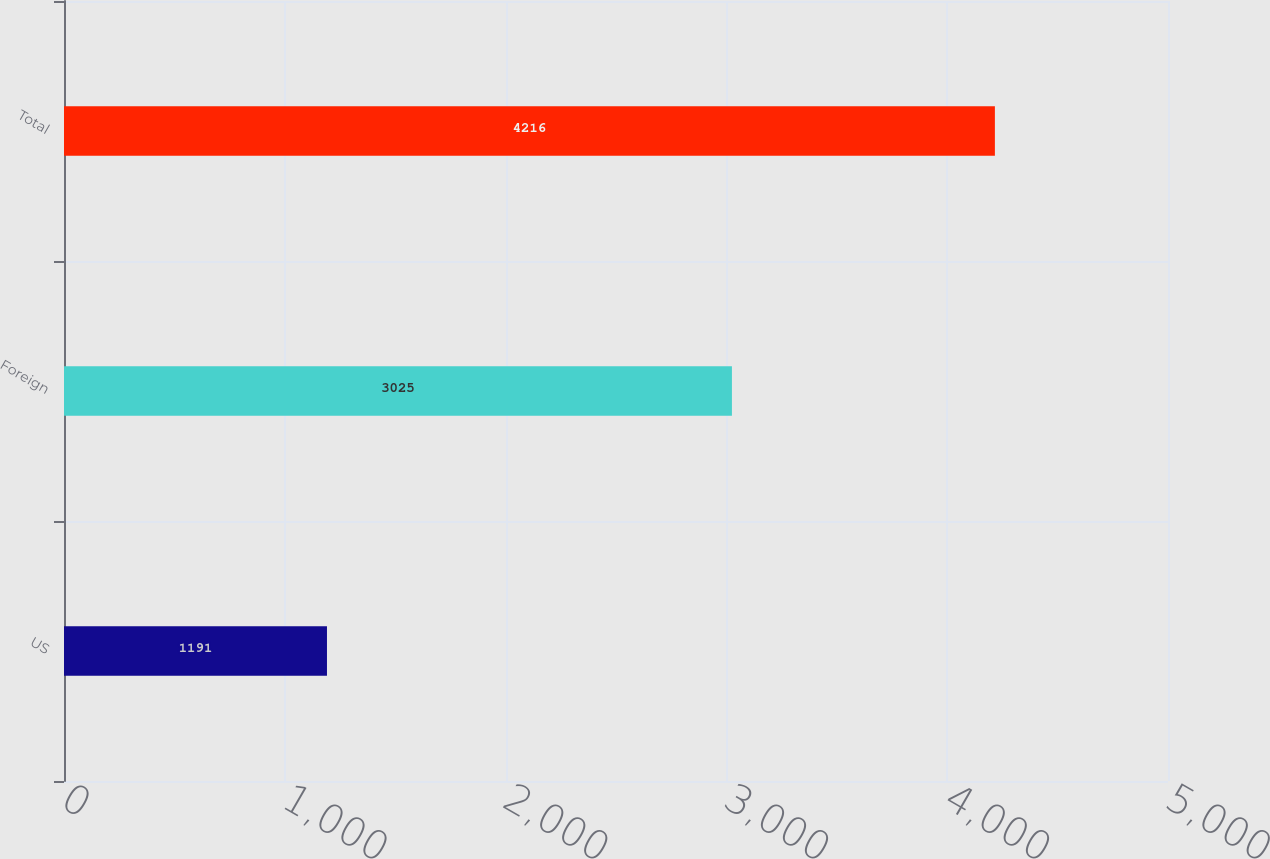Convert chart. <chart><loc_0><loc_0><loc_500><loc_500><bar_chart><fcel>US<fcel>Foreign<fcel>Total<nl><fcel>1191<fcel>3025<fcel>4216<nl></chart> 